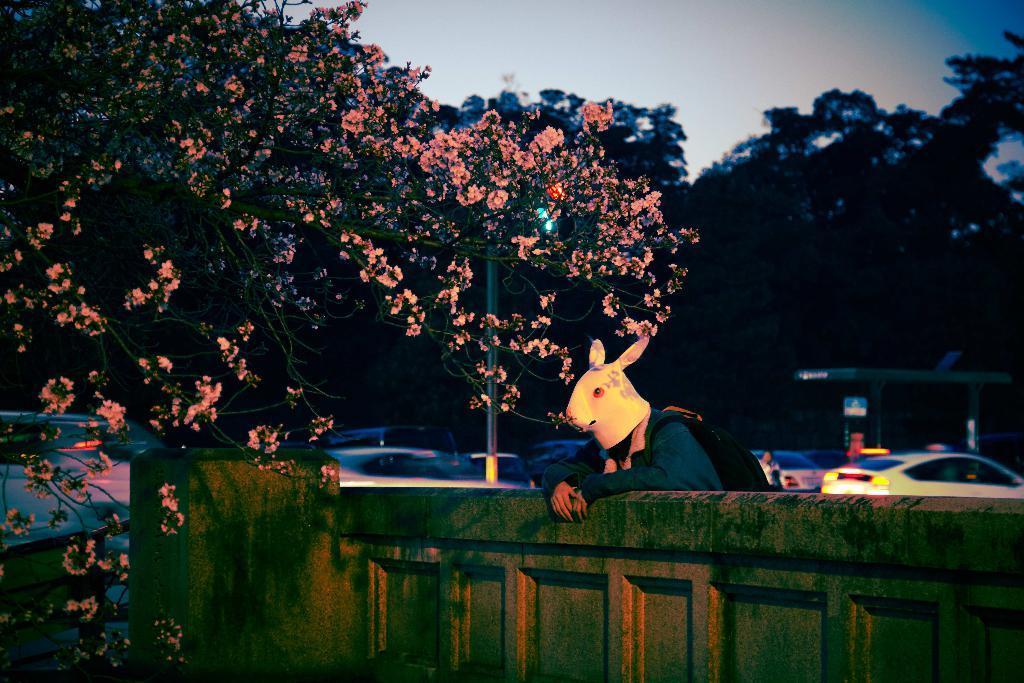In one or two sentences, can you explain what this image depicts? In this image we can see a boundary wall. Behind the wall we can see a man is wearing animal mask and carrying bag. In the background, we can see trees, pole and cars. At the top of the image, we can see the sky. We can see a shelter on the right side of the image. 